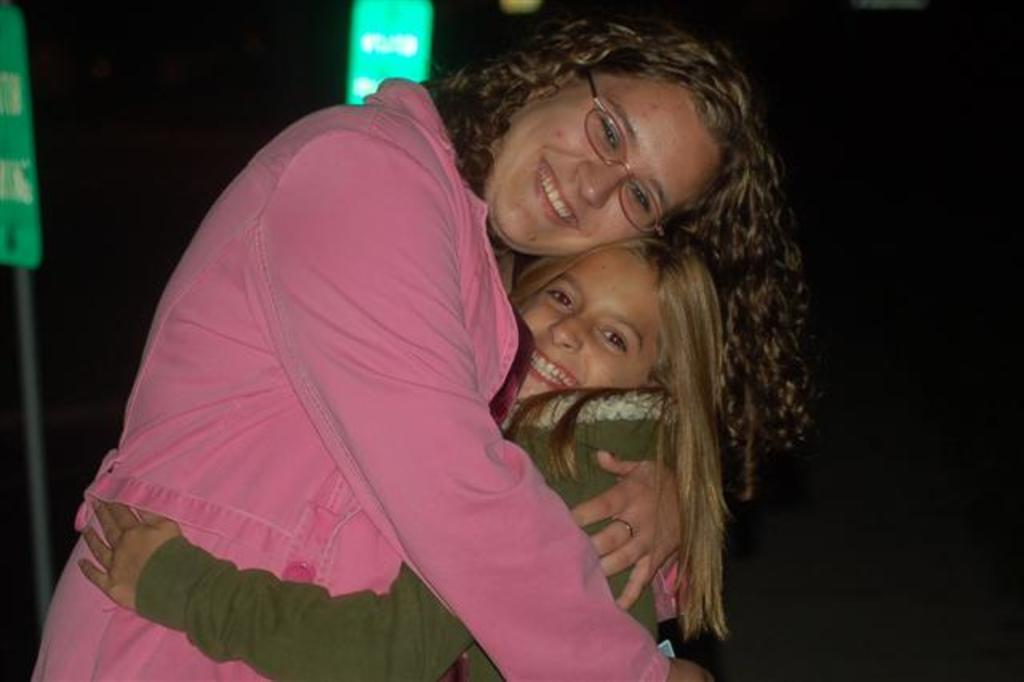Who is present in the image? There is a woman and a kid in the image. What are the woman and the kid wearing? The woman is wearing a pink dress, and the kid is wearing a green dress. What are the woman and the kid doing in the image? The woman and the kid are hugging each other. What can be seen in the background of the image? The background of the image has a dark view. What shape is the vessel used by the woman and the kid in the image? There is no vessel present in the image; it is a scene of the woman and the kid hugging each other. What act are the woman and the kid performing in the image? The woman and the kid are hugging each other, as mentioned in the conversation. 